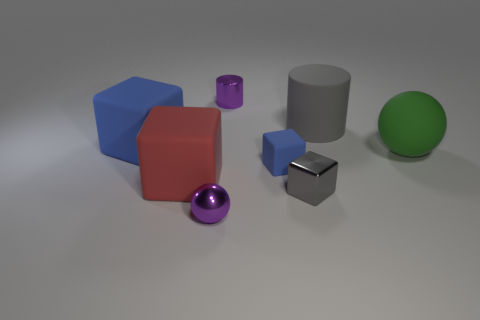Subtract all green balls. How many blue cubes are left? 2 Subtract all gray blocks. How many blocks are left? 3 Subtract 1 blocks. How many blocks are left? 3 Add 1 gray rubber balls. How many objects exist? 9 Subtract all red blocks. How many blocks are left? 3 Subtract all cylinders. How many objects are left? 6 Subtract all yellow cubes. Subtract all gray cylinders. How many cubes are left? 4 Subtract 0 purple blocks. How many objects are left? 8 Subtract all blue matte things. Subtract all big matte cylinders. How many objects are left? 5 Add 4 red rubber cubes. How many red rubber cubes are left? 5 